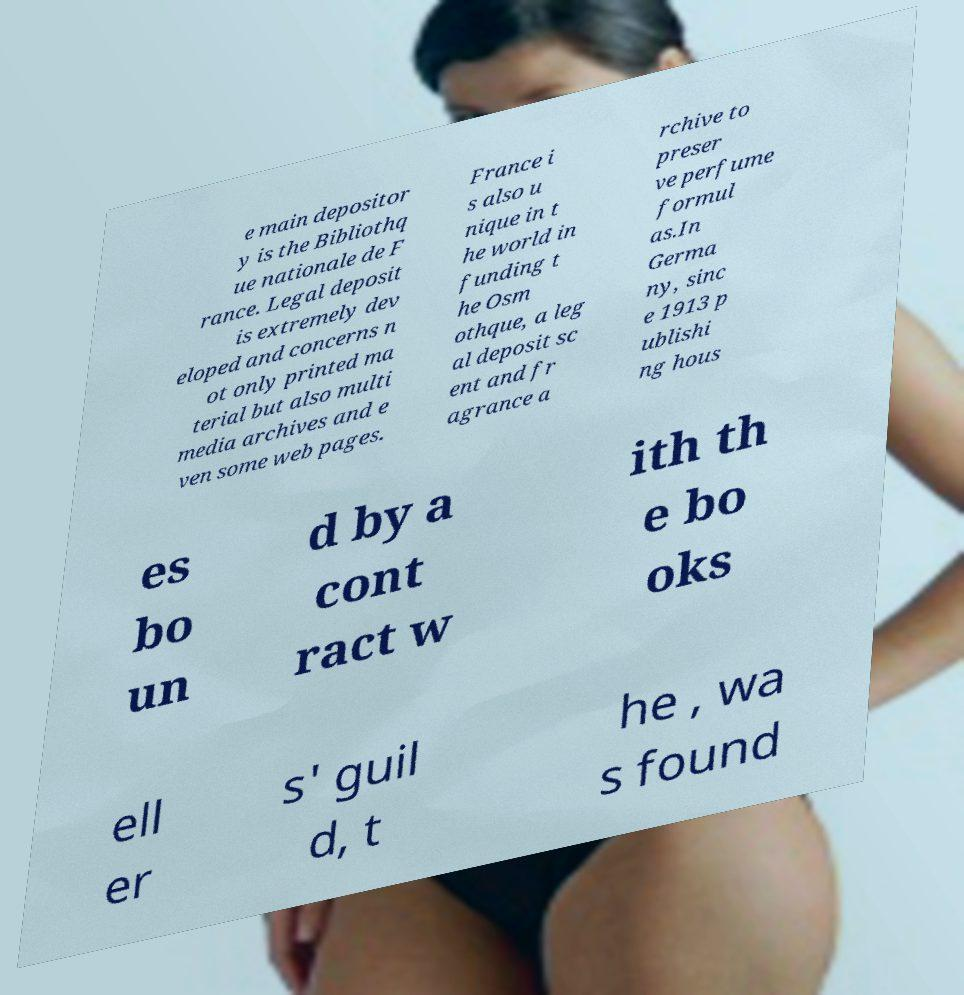I need the written content from this picture converted into text. Can you do that? e main depositor y is the Bibliothq ue nationale de F rance. Legal deposit is extremely dev eloped and concerns n ot only printed ma terial but also multi media archives and e ven some web pages. France i s also u nique in t he world in funding t he Osm othque, a leg al deposit sc ent and fr agrance a rchive to preser ve perfume formul as.In Germa ny, sinc e 1913 p ublishi ng hous es bo un d by a cont ract w ith th e bo oks ell er s' guil d, t he , wa s found 